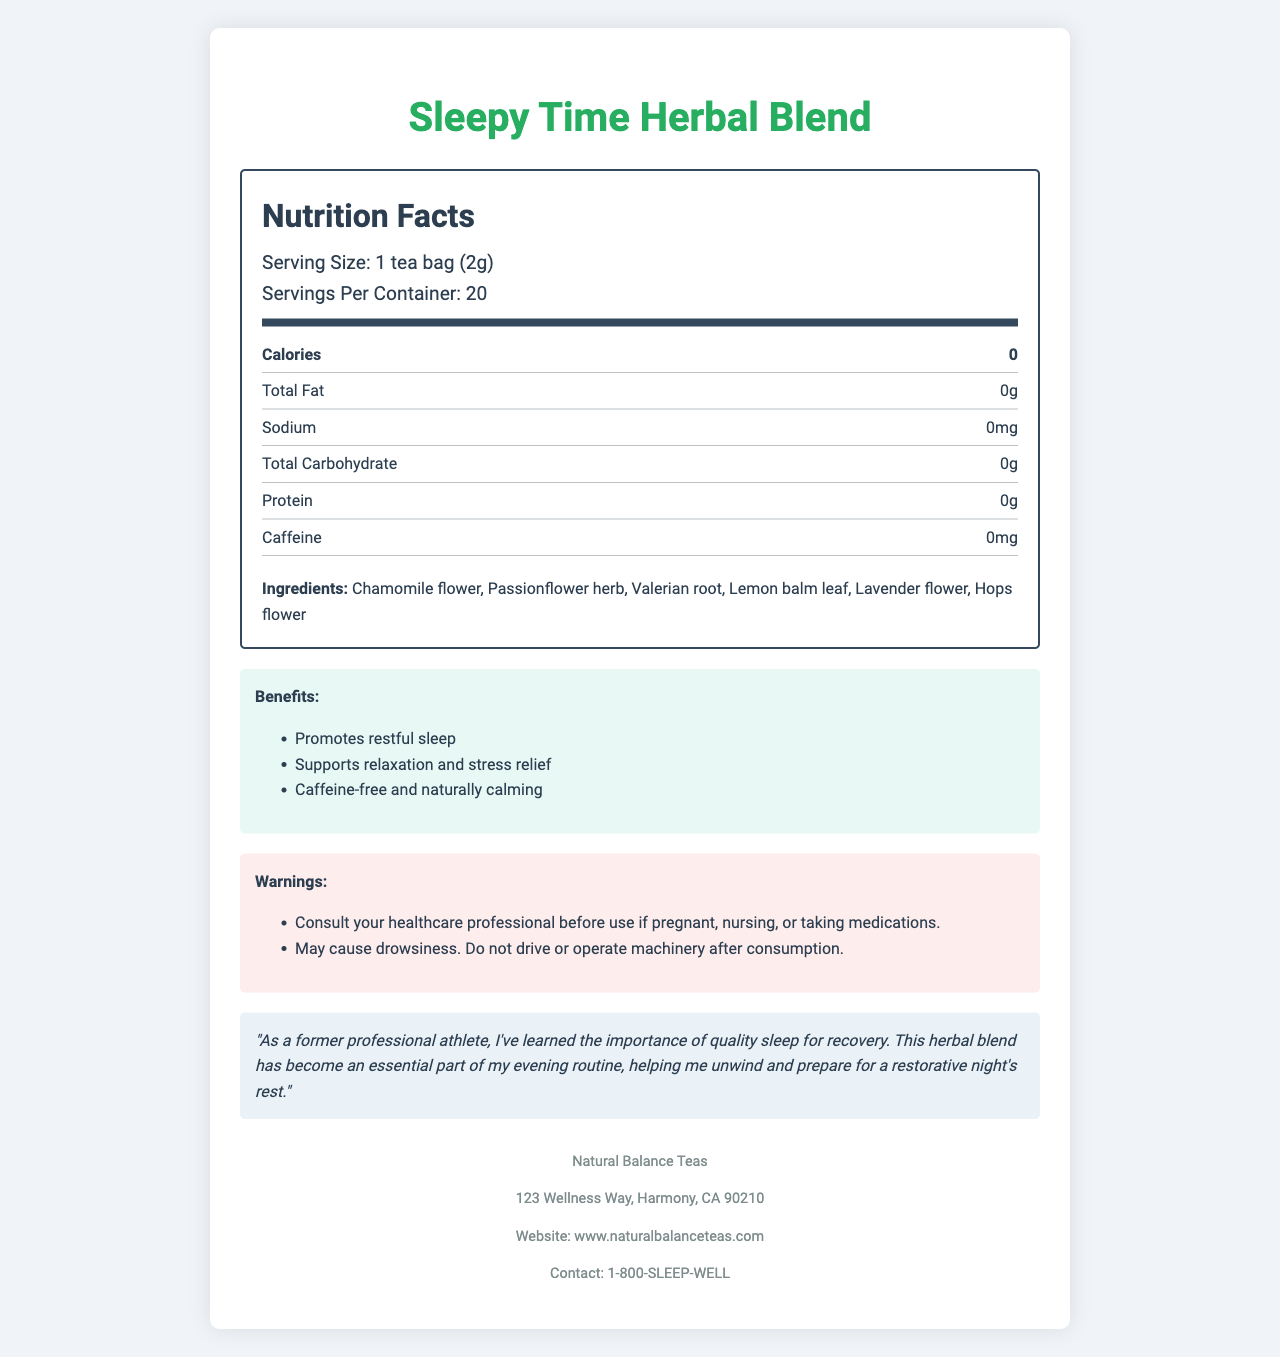what is the serving size? The document specifies that the serving size is 1 tea bag, which weighs 2 grams.
Answer: 1 tea bag (2g) how many servings are there per container? The document states that there are 20 servings per container.
Answer: 20 what is the calorie content per serving? The Nutrition Facts section indicates that each serving contains 0 calories.
Answer: 0 calories what ingredients are included in this tea blend? The ingredients listed in the document are Chamomile flower, Passionflower herb, Valerian root, Lemon balm leaf, Lavender flower, and Hops flower.
Answer: Chamomile flower, Passionflower herb, Valerian root, Lemon balm leaf, Lavender flower, Hops flower how much caffeine is in each serving? The document specifies that there is 0mg of caffeine per serving.
Answer: 0mg which of the following vitamins or minerals are present in this tea? A. Vitamin A B. Vitamin C C. Calcium D. None of the above The document states that Vitamin A, Vitamin C, Calcium, and Iron are all present in 0% of the daily value, implying none of these nutrients are present in significant amounts.
Answer: D. None of the above what is one of the main benefits of this herbal blend according to the document? A. Weight loss B. Increased energy C. Restful sleep D. Improved digestion The benefits section highlights “Promotes restful sleep” as one of the main benefits.
Answer: C. Restful sleep can you consume this tea if you are pregnant without consulting a healthcare professional? The document contains a warning advising to consult a healthcare professional if pregnant, nursing, or taking medications before usage.
Answer: No does this tea contain any additives or preservatives? The ingredient list does not mention any additives or preservatives, implying it's free from such substances.
Answer: No why should you avoid driving after consuming this tea? The document warns that the tea may cause drowsiness and advises against driving or operating machinery after consumption.
Answer: May cause drowsiness who manufactures this tea? The company information at the end of the document states that the tea is manufactured by Natural Balance Teas.
Answer: Natural Balance Teas summarize the main purpose of this document. The document's main purpose is to inform the consumer about the nutritional value, benefits, ingredients, and safe usage of the Sleepy Time Herbal Blend tea, along with providing company information and a personal testimonial.
Answer: The document provides detailed nutrition and ingredient information about the Sleepy Time Herbal Blend tea, highlighting its zero-calorie content, caffeine-free nature, beneficial ingredients, and the restful sleep it promotes. It also includes warnings for pregnant or nursing individuals and those taking medications, as well as testimonial and company contact information. what is the preparation method for this tea? The preparation method indicated in the document is to steep the tea bag in hot water for 5-7 minutes.
Answer: Steep in hot water for 5-7 minutes what time of day is this tea best consumed? The athlete testimonial and the benefits section both imply that this tea is meant to promote restful sleep, suggesting it is best consumed in the evening or before bedtime.
Answer: Evening or before bedtime who provided the testimonial for this product? The document includes a testimonial from a "former professional athlete" about the benefits of the product.
Answer: A former professional athlete what is the company's contact phone number? The company information section lists the contact phone number as 1-800-SLEEP-WELL.
Answer: 1-800-SLEEP-WELL is there information about the environmental impact of this product in the document? The document does not provide any information about the environmental impact of the product.
Answer: No 